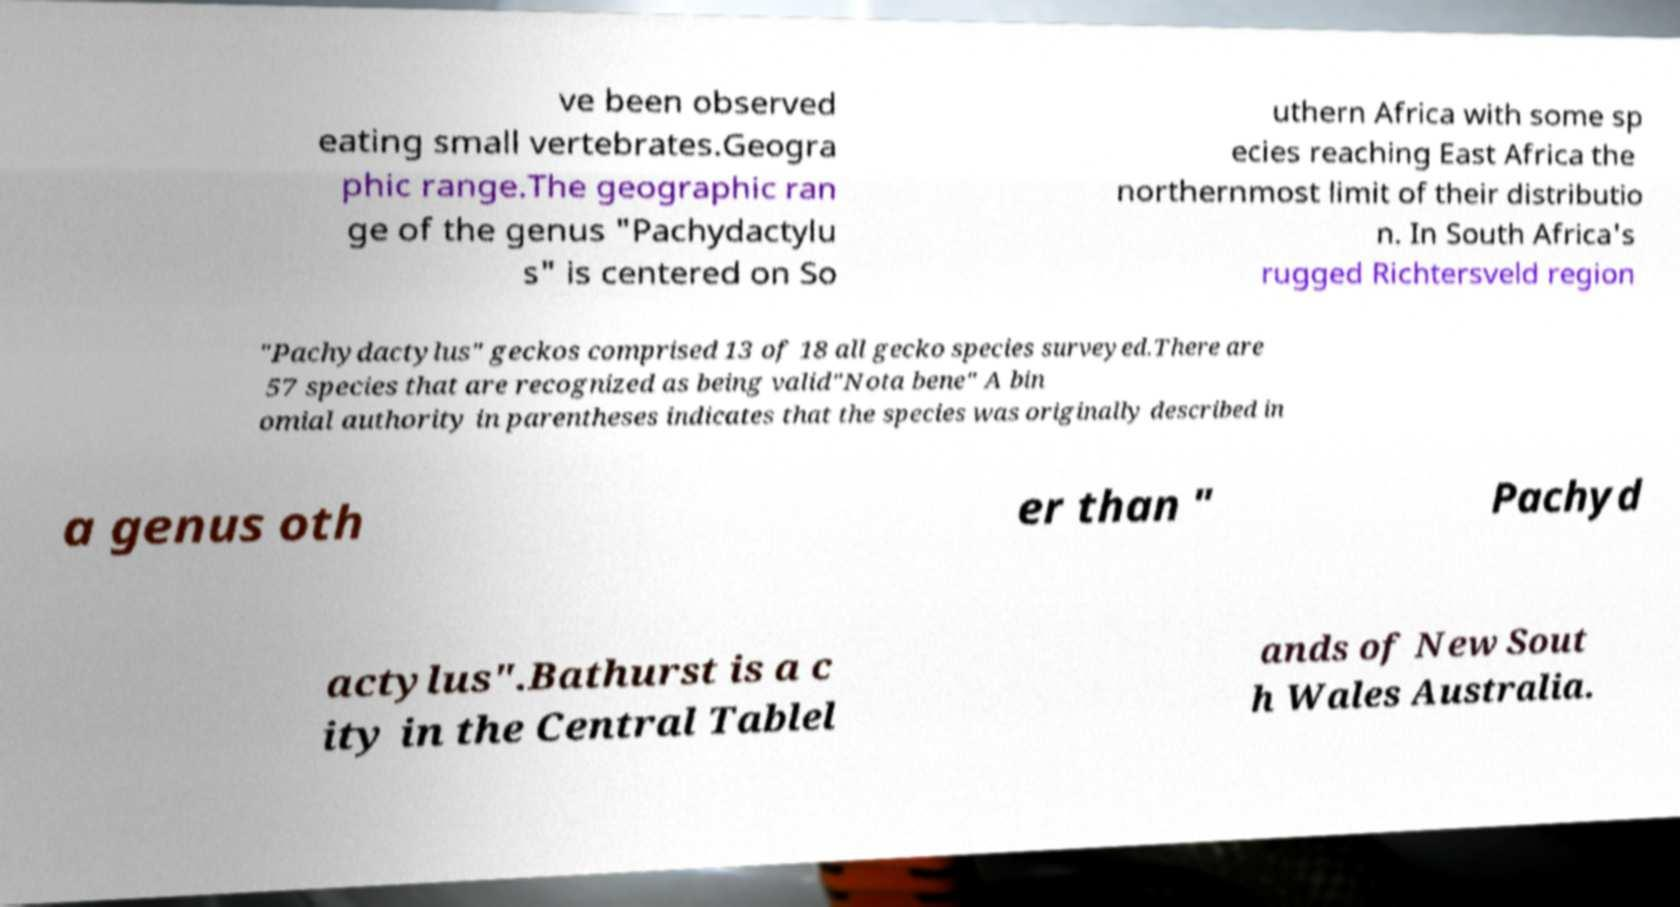Please identify and transcribe the text found in this image. ve been observed eating small vertebrates.Geogra phic range.The geographic ran ge of the genus "Pachydactylu s" is centered on So uthern Africa with some sp ecies reaching East Africa the northernmost limit of their distributio n. In South Africa's rugged Richtersveld region "Pachydactylus" geckos comprised 13 of 18 all gecko species surveyed.There are 57 species that are recognized as being valid"Nota bene" A bin omial authority in parentheses indicates that the species was originally described in a genus oth er than " Pachyd actylus".Bathurst is a c ity in the Central Tablel ands of New Sout h Wales Australia. 